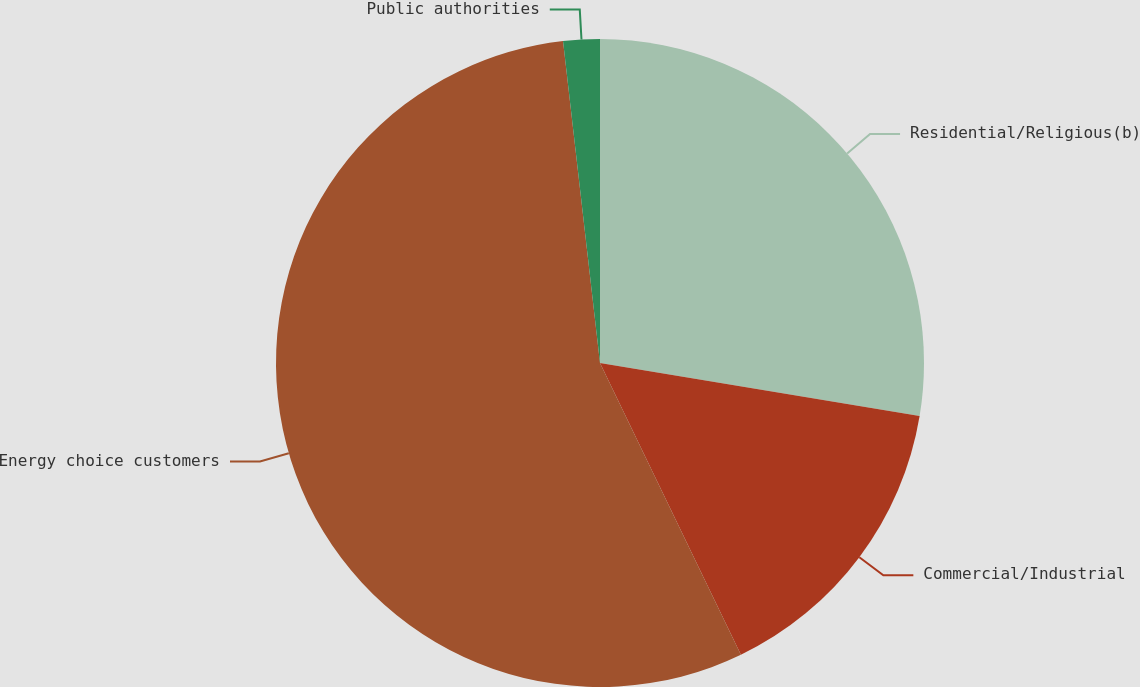Convert chart. <chart><loc_0><loc_0><loc_500><loc_500><pie_chart><fcel>Residential/Religious(b)<fcel>Commercial/Industrial<fcel>Energy choice customers<fcel>Public authorities<nl><fcel>27.62%<fcel>15.22%<fcel>55.34%<fcel>1.82%<nl></chart> 